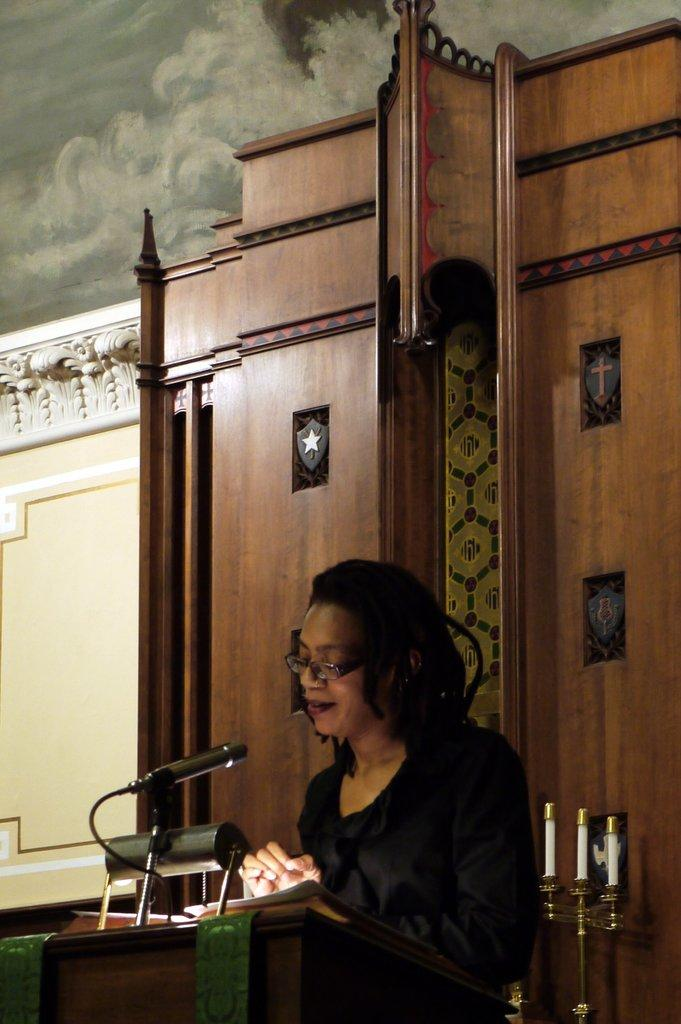What is the person in the image doing? There is a person standing in the image, but their activity is not specified. What is located on the podium in the image? A microphone, a lamp, and a book are present on the podium in the image. What is the podium standing on? The podium is on a wooden board. What other objects are visible in the image? There are candles on a candle stand. How many cows are grazing on the wooden board in the image? There are no cows present in the image; the wooden board is supporting the podium. What type of lumber is used to make the candles in the image? There are no candles made of lumber in the image; the candles are on a candle stand. 